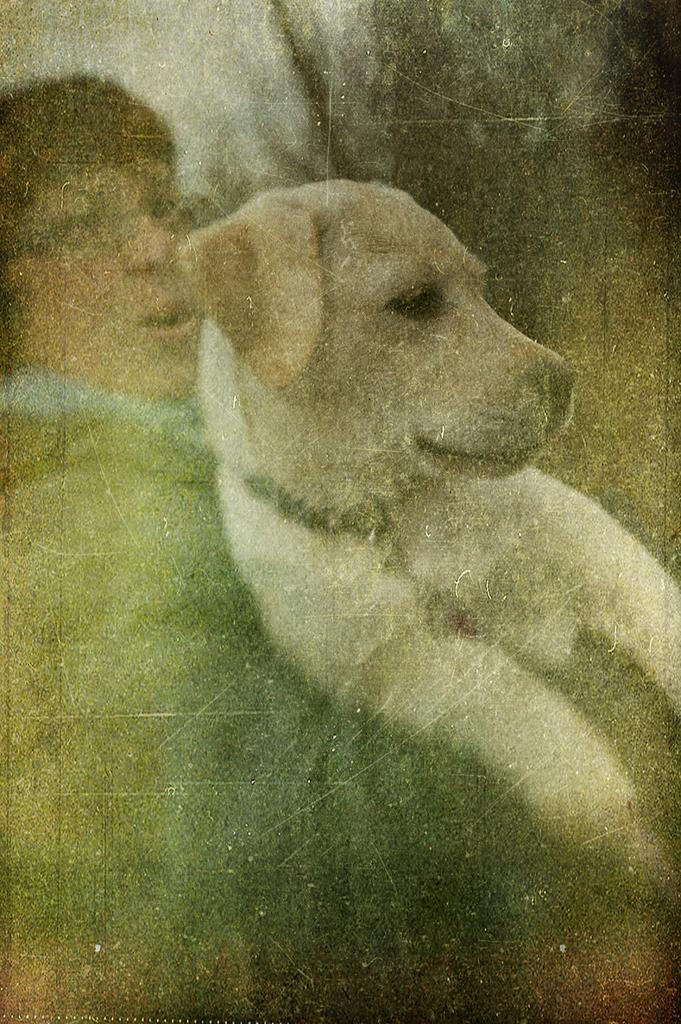Can you describe this image briefly? In this picture I can see a human holding a dog and I can see a blurry background. 